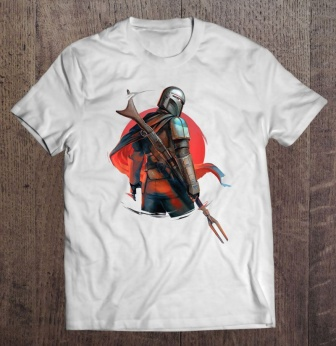What do you think is going on in this snapshot?
 The image showcases a white t-shirt, laid flat on a wooden surface, adorned with a graphic design. The design is a vivid depiction of a knight in armor, standing resolute against a backdrop of a red circle. The knight, armored in hues of blue and silver, wields a sword in his right hand and a spear in his left. The sword and spear, crafted in shades of brown and silver, add to the knight's imposing presence. A helmet, complete with a plume, rests on the knight's head, further enhancing the medieval theme of the design. The knight's stance and the detailed design elements create a dynamic visual narrative on the t-shirt. 